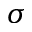<formula> <loc_0><loc_0><loc_500><loc_500>\sigma</formula> 